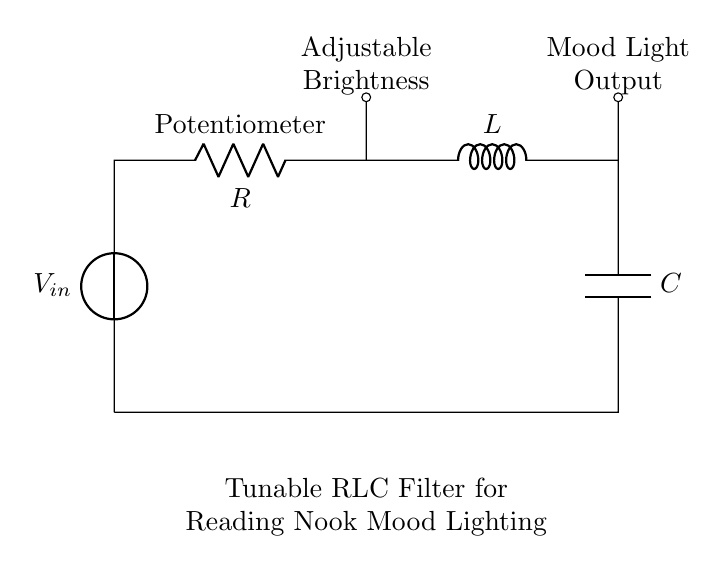What is the main purpose of this circuit? The circuit is designed as a tunable RLC filter to adjust the mood lighting in reading nooks.
Answer: tunable RLC filter What component is used to adjust the brightness? The brightness is adjusted using a potentiometer, which varies the resistance in the circuit.
Answer: Potentiometer How many main components are in this circuit? The circuit contains three main components: a resistor, an inductor, and a capacitor, collectively making the RLC circuit.
Answer: three What type of filter does this circuit represent? The circuit represents a tunable filter, suitable for selecting frequency response to adjust light mood.
Answer: tunable filter What is the voltage source label in the diagram? The voltage source in the circuit is labeled as V-in, indicating the input voltage to the circuit.
Answer: V-in How does the inductor affect the circuit's performance? The inductor influences the filter's frequency response, allowing selective tuning of the circuit for desired lighting effects.
Answer: selective tuning What is the main output of this circuit? The main output of the circuit is the mood light output, which interacts with the adjusted settings to control light intensity.
Answer: Mood Light Output 